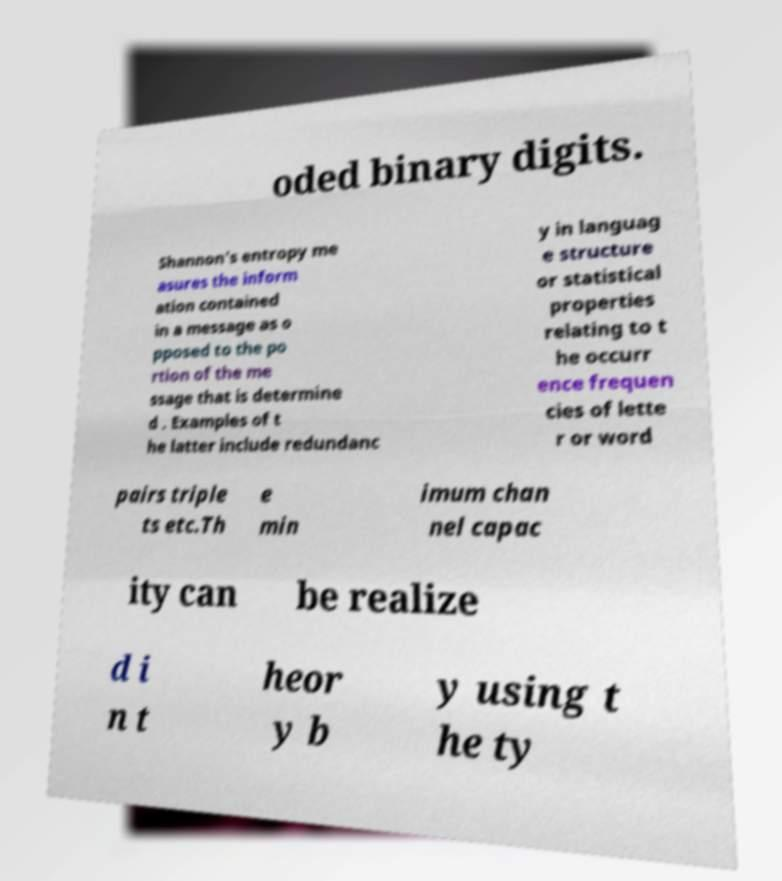Please identify and transcribe the text found in this image. oded binary digits. Shannon's entropy me asures the inform ation contained in a message as o pposed to the po rtion of the me ssage that is determine d . Examples of t he latter include redundanc y in languag e structure or statistical properties relating to t he occurr ence frequen cies of lette r or word pairs triple ts etc.Th e min imum chan nel capac ity can be realize d i n t heor y b y using t he ty 